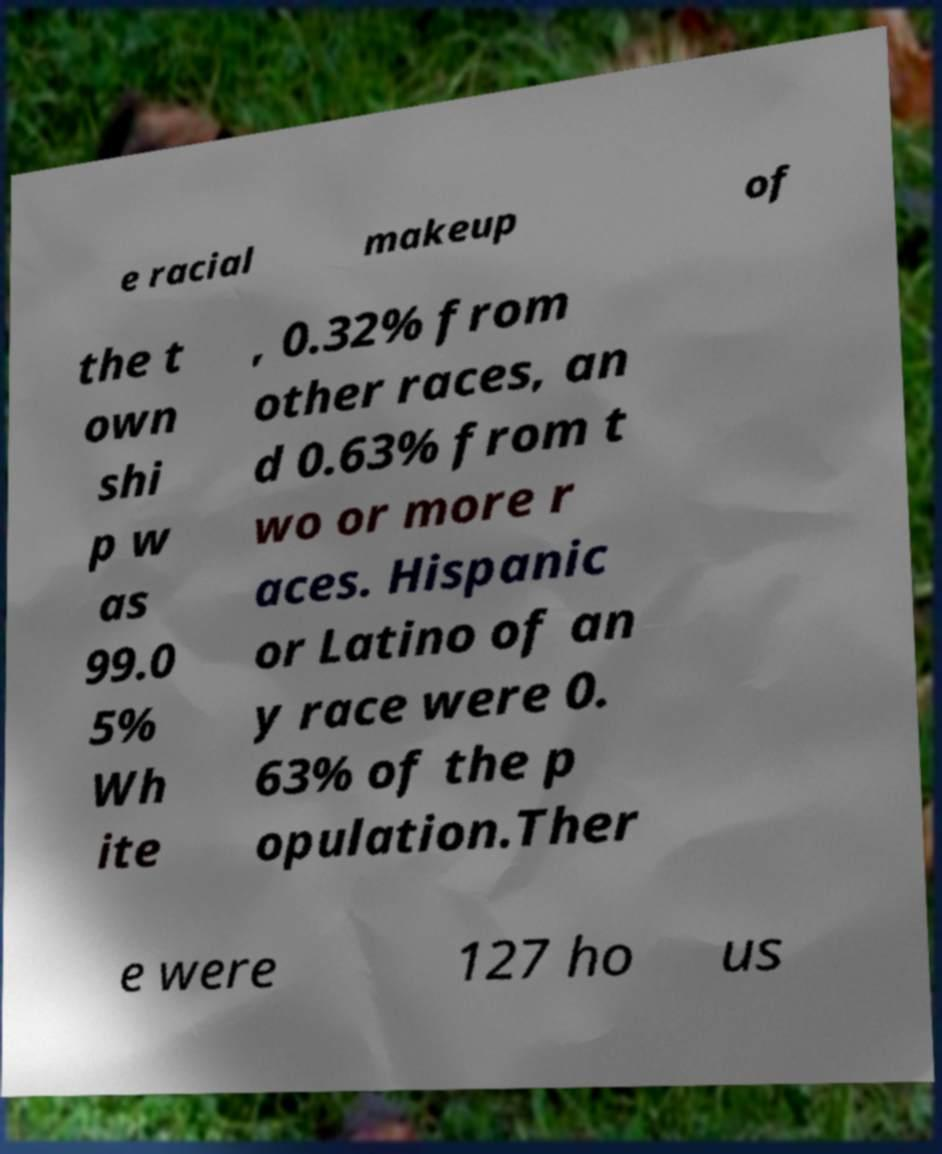Please identify and transcribe the text found in this image. e racial makeup of the t own shi p w as 99.0 5% Wh ite , 0.32% from other races, an d 0.63% from t wo or more r aces. Hispanic or Latino of an y race were 0. 63% of the p opulation.Ther e were 127 ho us 